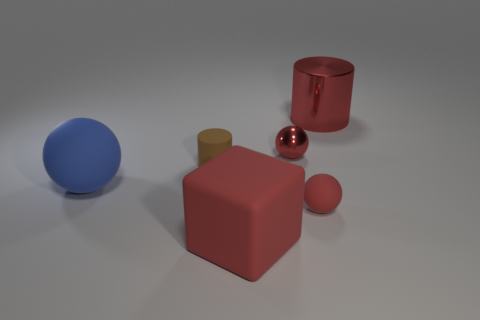How many things are either big red cubes or spheres that are in front of the tiny brown thing?
Offer a very short reply. 3. The ball that is left of the small red thing that is behind the small sphere that is in front of the large blue matte thing is what color?
Your answer should be compact. Blue. There is a red ball that is behind the tiny matte cylinder; how big is it?
Your answer should be very brief. Small. How many big objects are either red shiny cylinders or rubber objects?
Your answer should be compact. 3. There is a ball that is in front of the small metal thing and right of the big red rubber object; what color is it?
Make the answer very short. Red. Are there any other big blue things that have the same shape as the blue thing?
Your response must be concise. No. What is the brown cylinder made of?
Provide a succinct answer. Rubber. Are there any red matte cubes right of the tiny rubber sphere?
Offer a terse response. No. Do the small red shiny thing and the big red metallic object have the same shape?
Your answer should be compact. No. What number of other things are there of the same size as the metallic cylinder?
Your answer should be very brief. 2. 